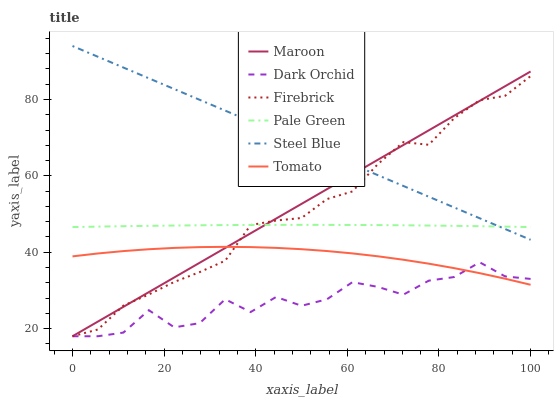Does Dark Orchid have the minimum area under the curve?
Answer yes or no. Yes. Does Steel Blue have the maximum area under the curve?
Answer yes or no. Yes. Does Firebrick have the minimum area under the curve?
Answer yes or no. No. Does Firebrick have the maximum area under the curve?
Answer yes or no. No. Is Maroon the smoothest?
Answer yes or no. Yes. Is Dark Orchid the roughest?
Answer yes or no. Yes. Is Firebrick the smoothest?
Answer yes or no. No. Is Firebrick the roughest?
Answer yes or no. No. Does Firebrick have the lowest value?
Answer yes or no. Yes. Does Steel Blue have the lowest value?
Answer yes or no. No. Does Steel Blue have the highest value?
Answer yes or no. Yes. Does Firebrick have the highest value?
Answer yes or no. No. Is Dark Orchid less than Pale Green?
Answer yes or no. Yes. Is Steel Blue greater than Tomato?
Answer yes or no. Yes. Does Dark Orchid intersect Tomato?
Answer yes or no. Yes. Is Dark Orchid less than Tomato?
Answer yes or no. No. Is Dark Orchid greater than Tomato?
Answer yes or no. No. Does Dark Orchid intersect Pale Green?
Answer yes or no. No. 